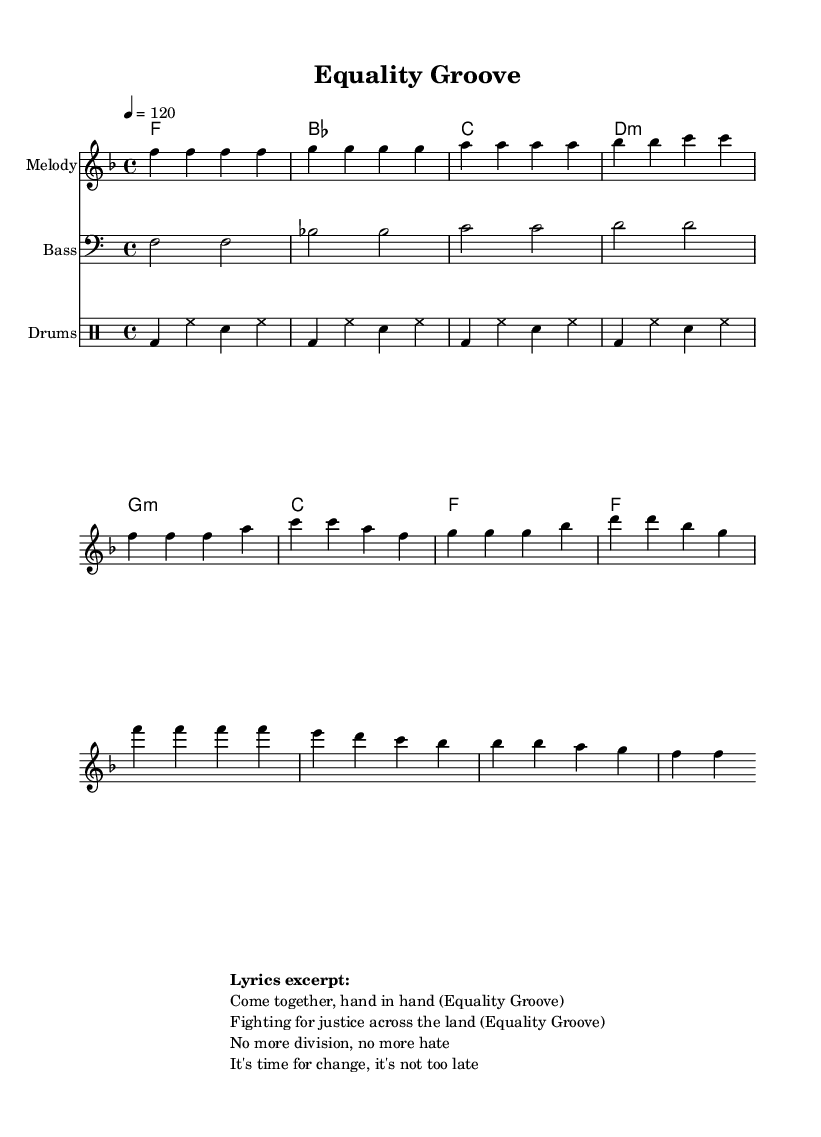What is the key signature of this music? The key signature is indicated at the beginning of the score and is F major, which has one flat (B).
Answer: F major What is the time signature of this piece? The time signature appears at the beginning of the score and shows the piece is in 4/4 time, meaning there are four beats in each measure.
Answer: 4/4 What is the tempo marking for the piece? The tempo marking is found in the global settings and shows that the piece should be played at a speed of quarter note equals 120 beats per minute.
Answer: 120 How many measures are in the melody section? By counting the measures in the melody line, there are a total of 8 measures in the provided melody section.
Answer: 8 What note does the melody start on? The melody begins on the note F, the first note indicated in the melody line.
Answer: F What is the last note of the chorus section? In the melody line, the last note of the chorus is F, which appears at the end of the final measure indicated for the chorus.
Answer: F What social theme is reflected in the lyrics excerpt? The lyrics mention a fight for justice, equality, and a call for change, reflecting themes of social justice and unity.
Answer: Social justice 